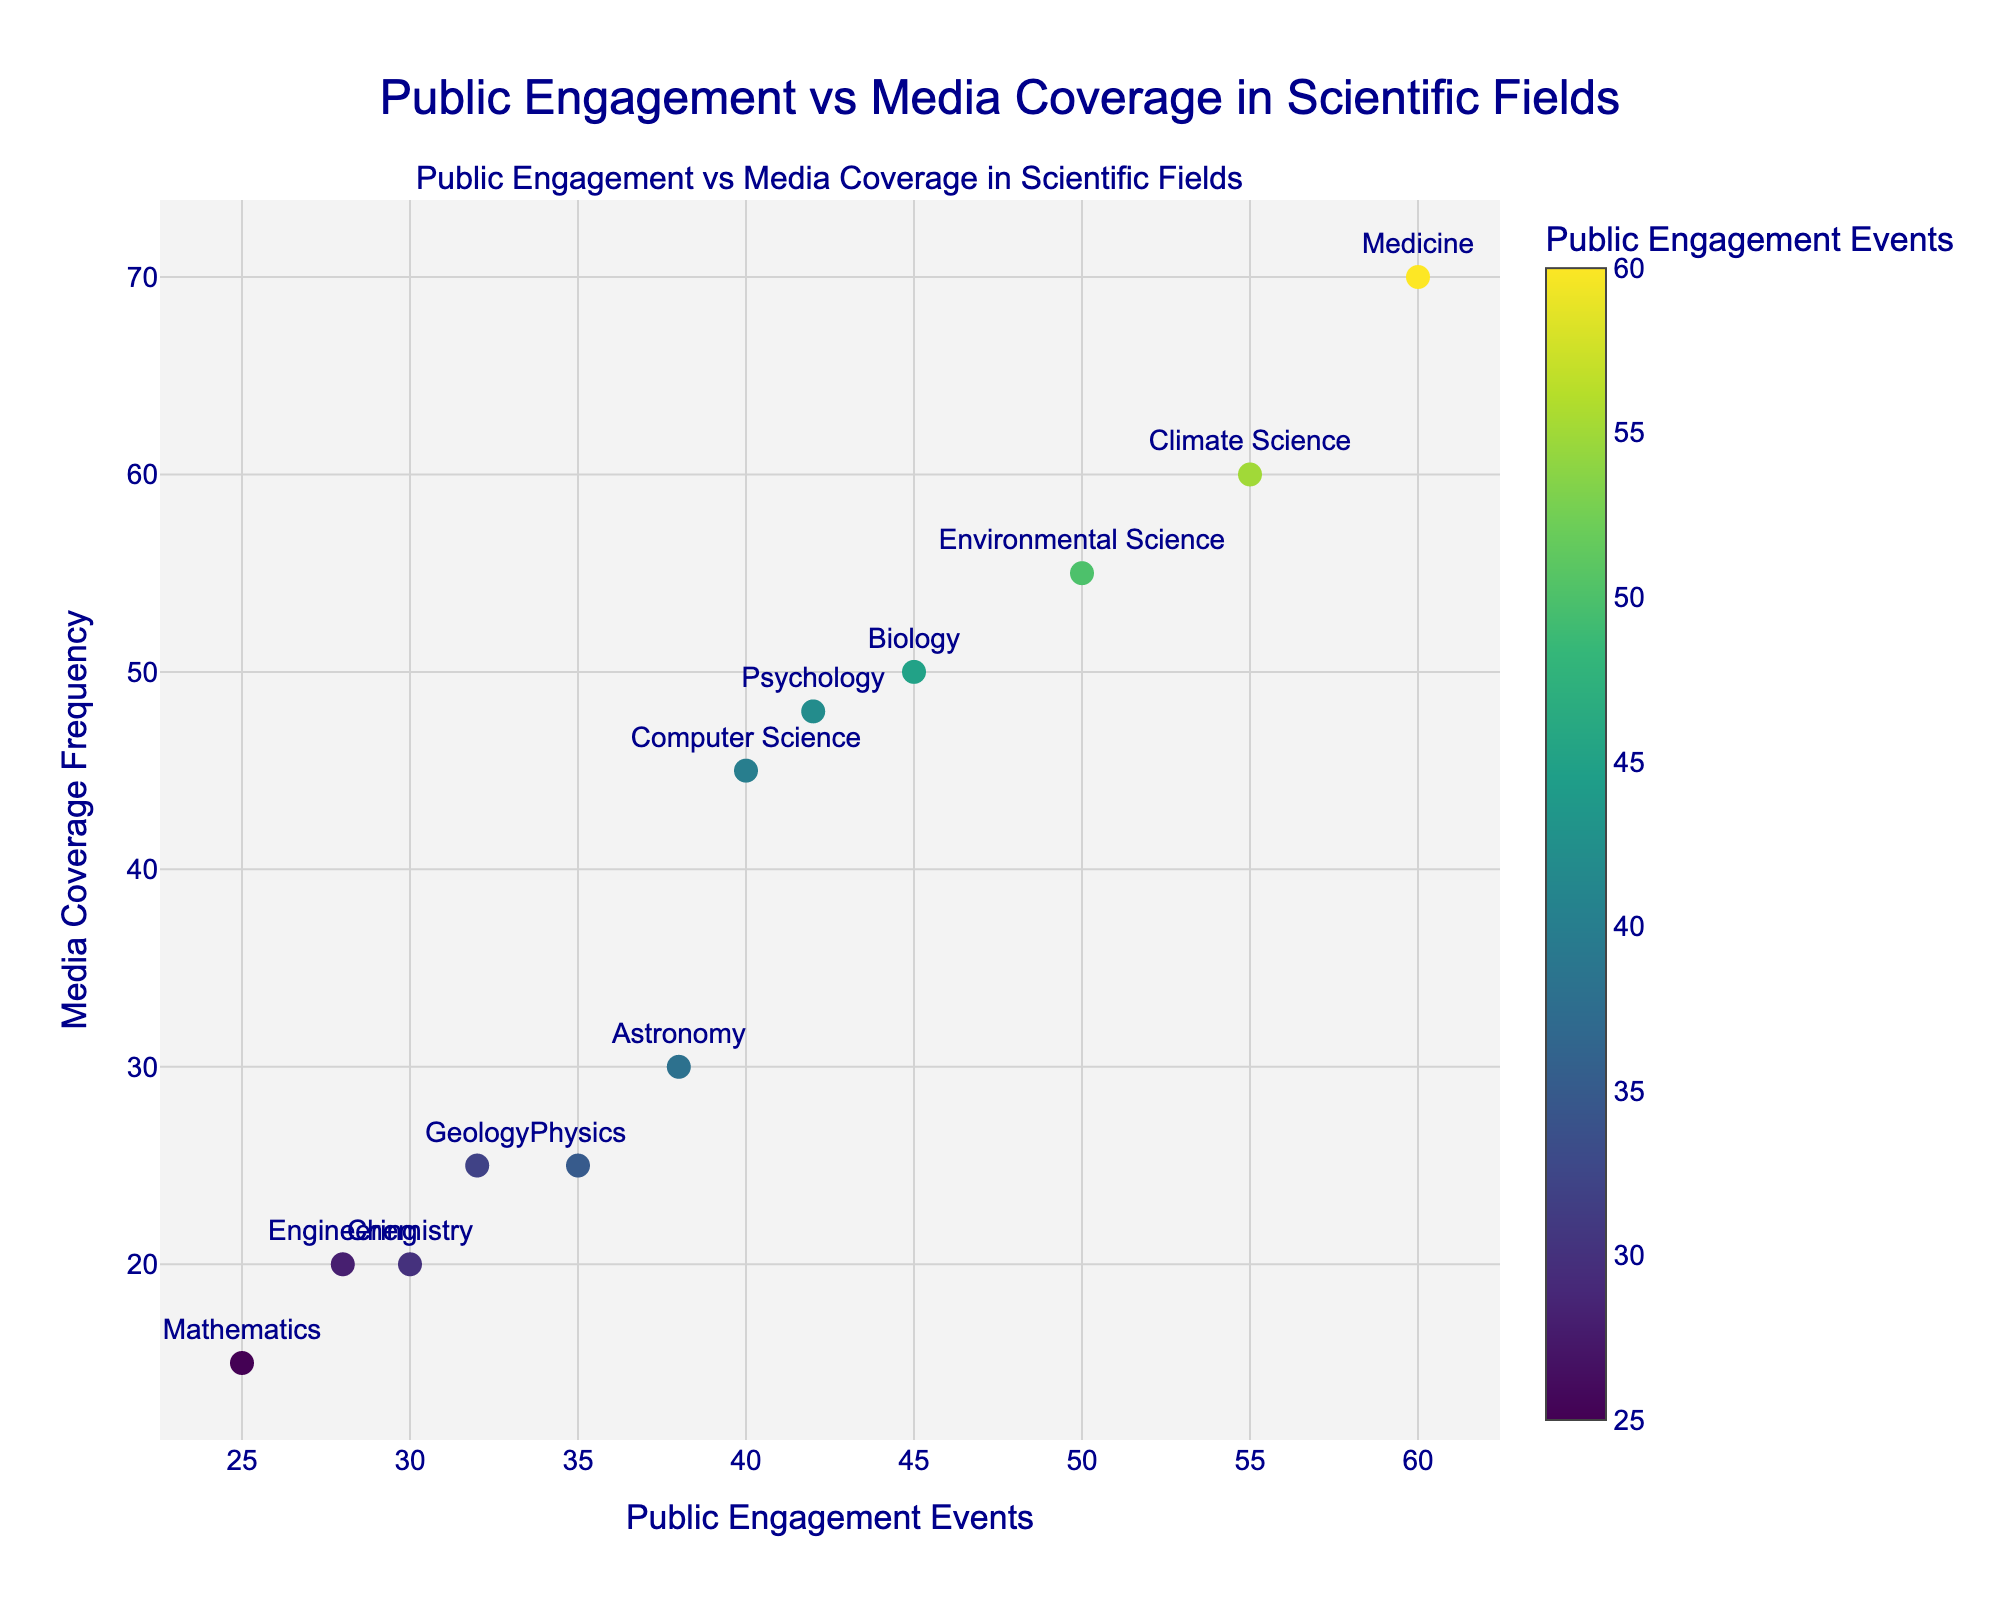What's the title of the figure? The title is usually placed at the top center of the figure, and in this case, it is specified in the 'title' part of the layout.
Answer: Public Engagement vs Media Coverage in Scientific Fields Which field has the highest number of public engagement events? Look for the marker value furthest along the x-axis. The point with the highest x-value corresponds to the field with the highest number of public engagement events.
Answer: Medicine What is the relationship between public engagement events and media coverage frequency for the field of Biology? Identify the point that is labeled as Biology and read its coordinates, which represent public engagement events and media coverage frequency.
Answer: Biology has 45 public engagement events and 50 media coverage frequency How many fields have public engagement events greater than 40? Count the number of points on the scatter plot where the x-value (public engagement events) is greater than 40.
Answer: 4 What is the average media coverage frequency for fields with more than 35 public engagement events? Identify the fields with more than 35 public engagement events and then calculate the average y-values (media coverage frequencies) of these points.
Answer: (25+50+55+45+48+70+60)/7 ≈ 50.43 Which fields have the same number of media coverage frequency? Look for points that align horizontally on the scatter plot, meaning they share the same y-value.
Answer: Chemistry and Engineering both have 20 media coverage frequency Is there a field with a higher number of public engagement events than Computer Science but a lower media coverage frequency? Compare each field's public engagement events and media coverage frequency against Computer Science (40, 45). Look for a point to the right (higher number of public engagement events) but below (lower media coverage frequency).
Answer: Medicine (60, 70) has higher values for both metrics Which field has the closest ratio of public engagement events to media coverage frequency? Calculate the ratio (public engagement events/media coverage frequency) for each field and find the field with the value closest to 1.
Answer: Environmental Science (50/55 ≈ 0.91) comes closest to a 1:1 ratio 